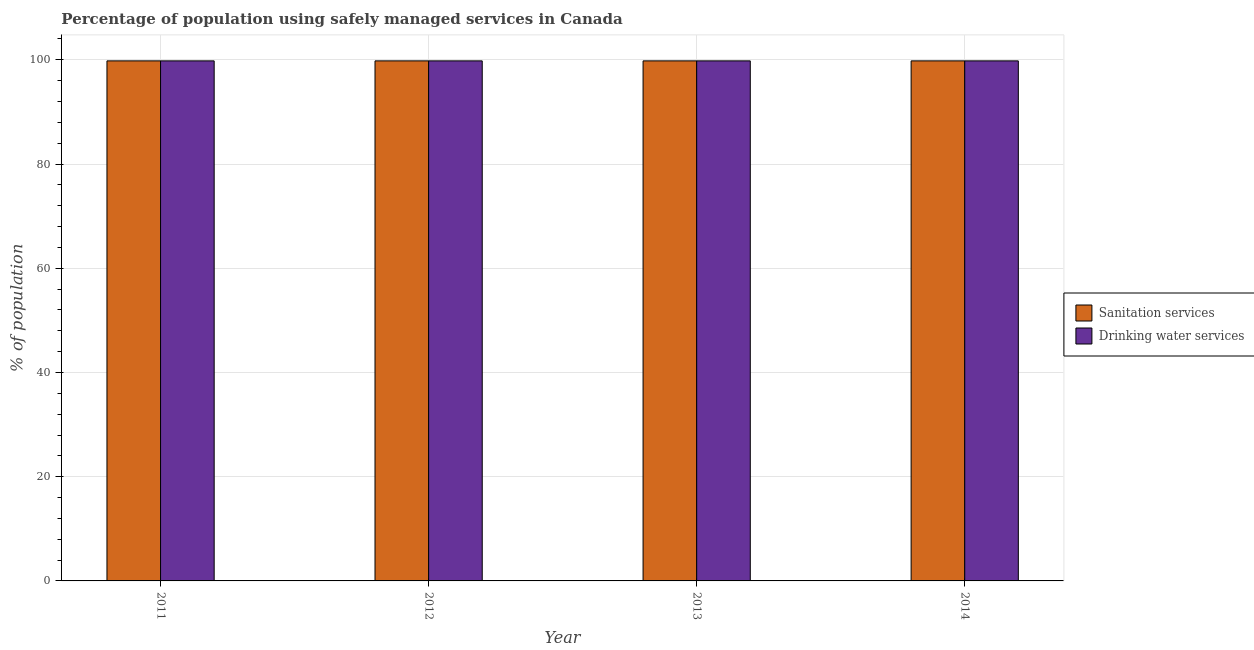Are the number of bars per tick equal to the number of legend labels?
Offer a very short reply. Yes. How many bars are there on the 2nd tick from the right?
Offer a very short reply. 2. What is the label of the 3rd group of bars from the left?
Give a very brief answer. 2013. In how many cases, is the number of bars for a given year not equal to the number of legend labels?
Give a very brief answer. 0. What is the percentage of population who used drinking water services in 2013?
Offer a terse response. 99.8. Across all years, what is the maximum percentage of population who used drinking water services?
Give a very brief answer. 99.8. Across all years, what is the minimum percentage of population who used sanitation services?
Ensure brevity in your answer.  99.8. In which year was the percentage of population who used sanitation services maximum?
Your response must be concise. 2011. In which year was the percentage of population who used sanitation services minimum?
Offer a terse response. 2011. What is the total percentage of population who used sanitation services in the graph?
Offer a very short reply. 399.2. What is the average percentage of population who used drinking water services per year?
Ensure brevity in your answer.  99.8. In how many years, is the percentage of population who used sanitation services greater than 28 %?
Give a very brief answer. 4. What is the ratio of the percentage of population who used sanitation services in 2011 to that in 2014?
Offer a very short reply. 1. Is the percentage of population who used sanitation services in 2011 less than that in 2012?
Ensure brevity in your answer.  No. Is the difference between the percentage of population who used sanitation services in 2011 and 2014 greater than the difference between the percentage of population who used drinking water services in 2011 and 2014?
Your answer should be very brief. No. What is the difference between the highest and the second highest percentage of population who used sanitation services?
Offer a terse response. 0. What is the difference between the highest and the lowest percentage of population who used drinking water services?
Your response must be concise. 0. What does the 2nd bar from the left in 2012 represents?
Keep it short and to the point. Drinking water services. What does the 1st bar from the right in 2014 represents?
Your answer should be very brief. Drinking water services. How many bars are there?
Provide a succinct answer. 8. How many years are there in the graph?
Provide a succinct answer. 4. What is the difference between two consecutive major ticks on the Y-axis?
Make the answer very short. 20. Are the values on the major ticks of Y-axis written in scientific E-notation?
Provide a succinct answer. No. How are the legend labels stacked?
Keep it short and to the point. Vertical. What is the title of the graph?
Make the answer very short. Percentage of population using safely managed services in Canada. Does "Secondary school" appear as one of the legend labels in the graph?
Provide a short and direct response. No. What is the label or title of the Y-axis?
Keep it short and to the point. % of population. What is the % of population of Sanitation services in 2011?
Give a very brief answer. 99.8. What is the % of population in Drinking water services in 2011?
Provide a short and direct response. 99.8. What is the % of population in Sanitation services in 2012?
Your response must be concise. 99.8. What is the % of population of Drinking water services in 2012?
Your response must be concise. 99.8. What is the % of population of Sanitation services in 2013?
Provide a short and direct response. 99.8. What is the % of population of Drinking water services in 2013?
Your answer should be very brief. 99.8. What is the % of population in Sanitation services in 2014?
Offer a very short reply. 99.8. What is the % of population in Drinking water services in 2014?
Give a very brief answer. 99.8. Across all years, what is the maximum % of population in Sanitation services?
Your response must be concise. 99.8. Across all years, what is the maximum % of population of Drinking water services?
Make the answer very short. 99.8. Across all years, what is the minimum % of population in Sanitation services?
Your answer should be compact. 99.8. Across all years, what is the minimum % of population of Drinking water services?
Provide a short and direct response. 99.8. What is the total % of population in Sanitation services in the graph?
Offer a very short reply. 399.2. What is the total % of population in Drinking water services in the graph?
Provide a short and direct response. 399.2. What is the difference between the % of population of Sanitation services in 2011 and that in 2012?
Your response must be concise. 0. What is the difference between the % of population in Sanitation services in 2011 and that in 2013?
Ensure brevity in your answer.  0. What is the difference between the % of population in Drinking water services in 2011 and that in 2013?
Your answer should be very brief. 0. What is the difference between the % of population of Sanitation services in 2011 and that in 2014?
Your answer should be very brief. 0. What is the difference between the % of population of Sanitation services in 2013 and that in 2014?
Ensure brevity in your answer.  0. What is the difference between the % of population of Drinking water services in 2013 and that in 2014?
Offer a terse response. 0. What is the difference between the % of population in Sanitation services in 2011 and the % of population in Drinking water services in 2013?
Offer a very short reply. 0. What is the difference between the % of population in Sanitation services in 2012 and the % of population in Drinking water services in 2013?
Your answer should be compact. 0. What is the difference between the % of population in Sanitation services in 2012 and the % of population in Drinking water services in 2014?
Make the answer very short. 0. What is the average % of population of Sanitation services per year?
Provide a succinct answer. 99.8. What is the average % of population of Drinking water services per year?
Ensure brevity in your answer.  99.8. In the year 2011, what is the difference between the % of population of Sanitation services and % of population of Drinking water services?
Your answer should be very brief. 0. In the year 2012, what is the difference between the % of population in Sanitation services and % of population in Drinking water services?
Your answer should be very brief. 0. In the year 2013, what is the difference between the % of population in Sanitation services and % of population in Drinking water services?
Provide a short and direct response. 0. In the year 2014, what is the difference between the % of population of Sanitation services and % of population of Drinking water services?
Provide a succinct answer. 0. What is the ratio of the % of population of Sanitation services in 2011 to that in 2012?
Your response must be concise. 1. What is the ratio of the % of population of Sanitation services in 2011 to that in 2013?
Offer a terse response. 1. What is the ratio of the % of population of Drinking water services in 2011 to that in 2013?
Your answer should be very brief. 1. What is the ratio of the % of population of Drinking water services in 2011 to that in 2014?
Your answer should be very brief. 1. What is the ratio of the % of population of Sanitation services in 2012 to that in 2013?
Offer a terse response. 1. What is the ratio of the % of population in Sanitation services in 2012 to that in 2014?
Keep it short and to the point. 1. What is the ratio of the % of population of Drinking water services in 2013 to that in 2014?
Offer a terse response. 1. What is the difference between the highest and the second highest % of population of Sanitation services?
Your answer should be compact. 0. What is the difference between the highest and the second highest % of population of Drinking water services?
Your response must be concise. 0. What is the difference between the highest and the lowest % of population in Drinking water services?
Provide a succinct answer. 0. 